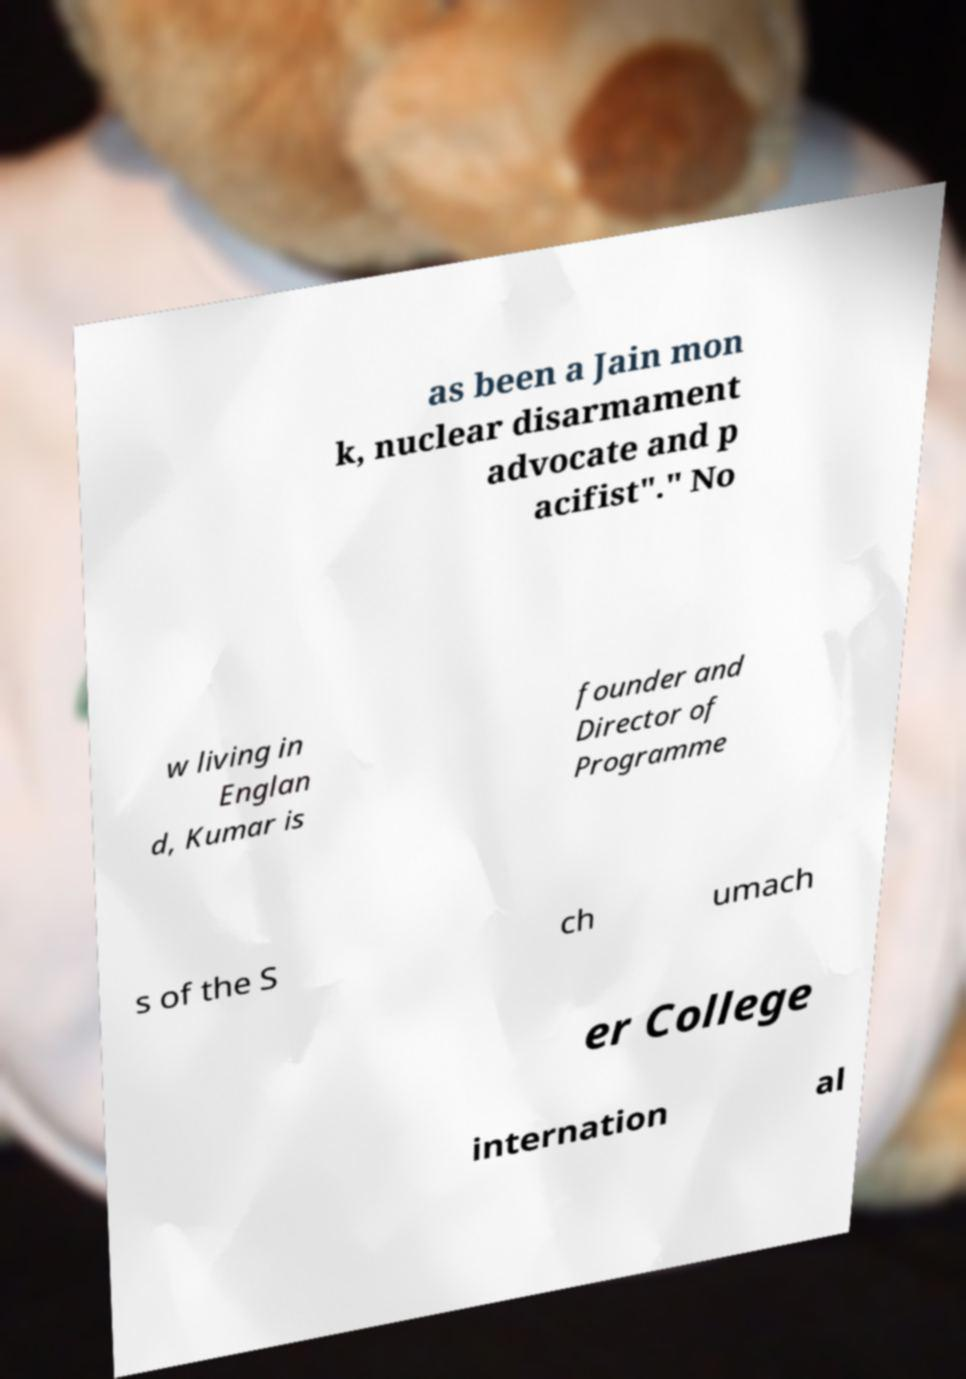Could you assist in decoding the text presented in this image and type it out clearly? as been a Jain mon k, nuclear disarmament advocate and p acifist"." No w living in Englan d, Kumar is founder and Director of Programme s of the S ch umach er College internation al 